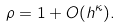<formula> <loc_0><loc_0><loc_500><loc_500>\rho = 1 + O ( h ^ { \kappa } ) .</formula> 